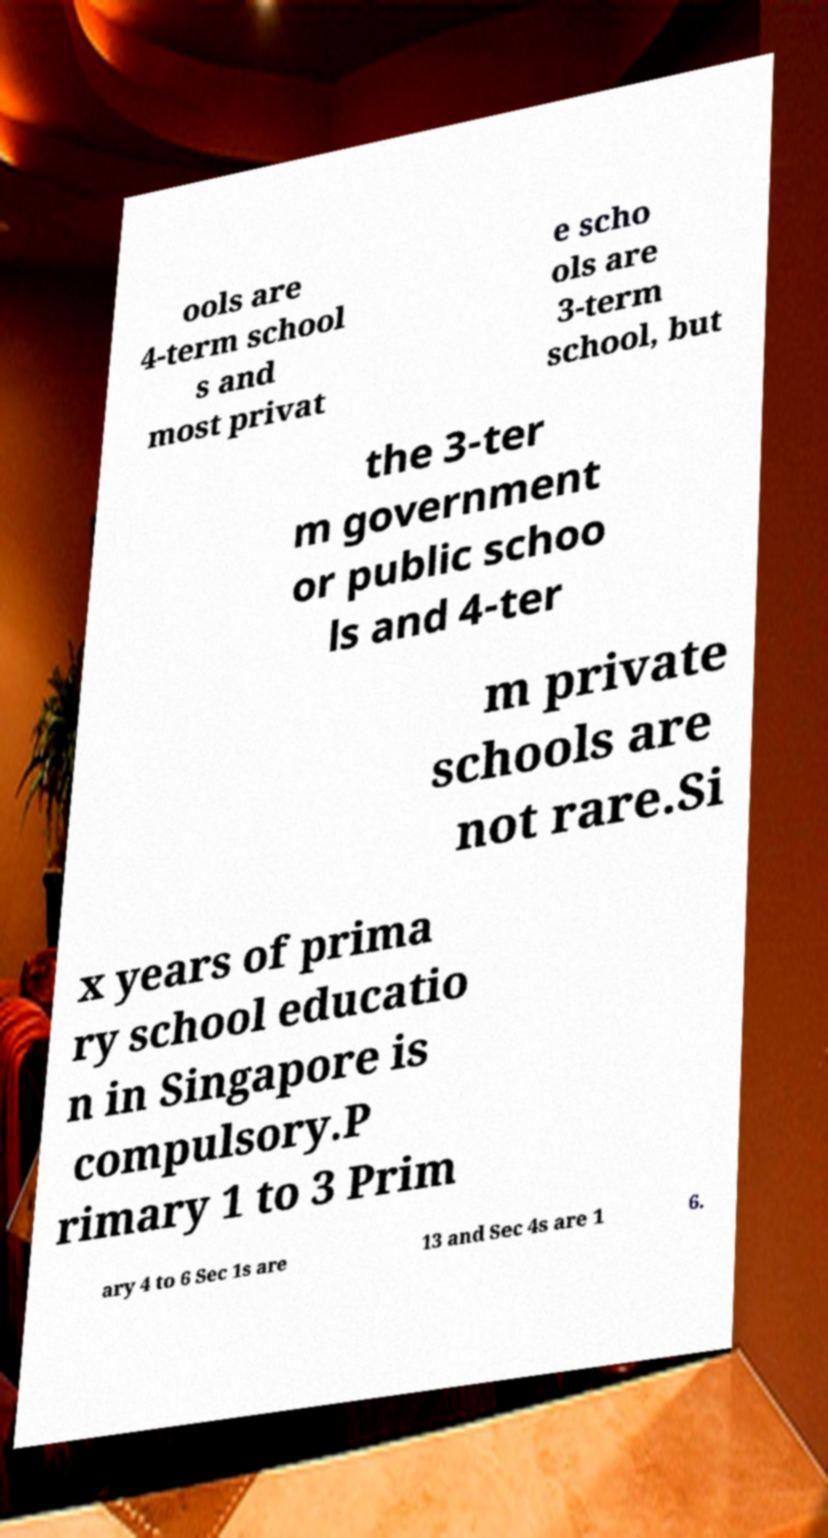Can you accurately transcribe the text from the provided image for me? ools are 4-term school s and most privat e scho ols are 3-term school, but the 3-ter m government or public schoo ls and 4-ter m private schools are not rare.Si x years of prima ry school educatio n in Singapore is compulsory.P rimary 1 to 3 Prim ary 4 to 6 Sec 1s are 13 and Sec 4s are 1 6. 